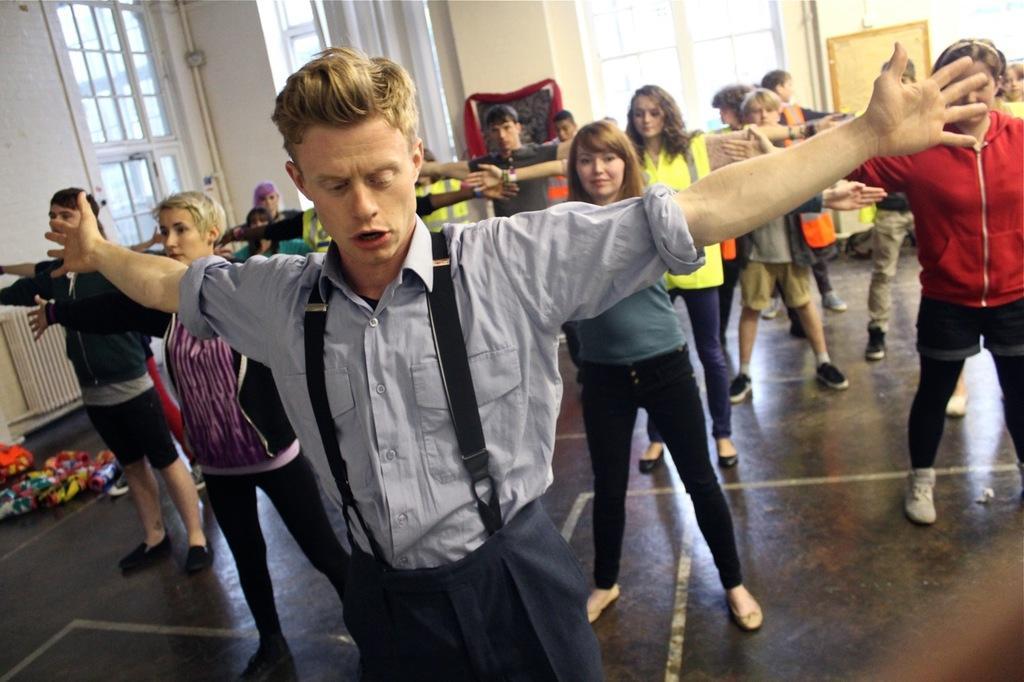Could you give a brief overview of what you see in this image? At the bottom of this image, there are persons in different color dresses, doing exercise on a floor. In the background, there are windows, a mirror and a wall. 